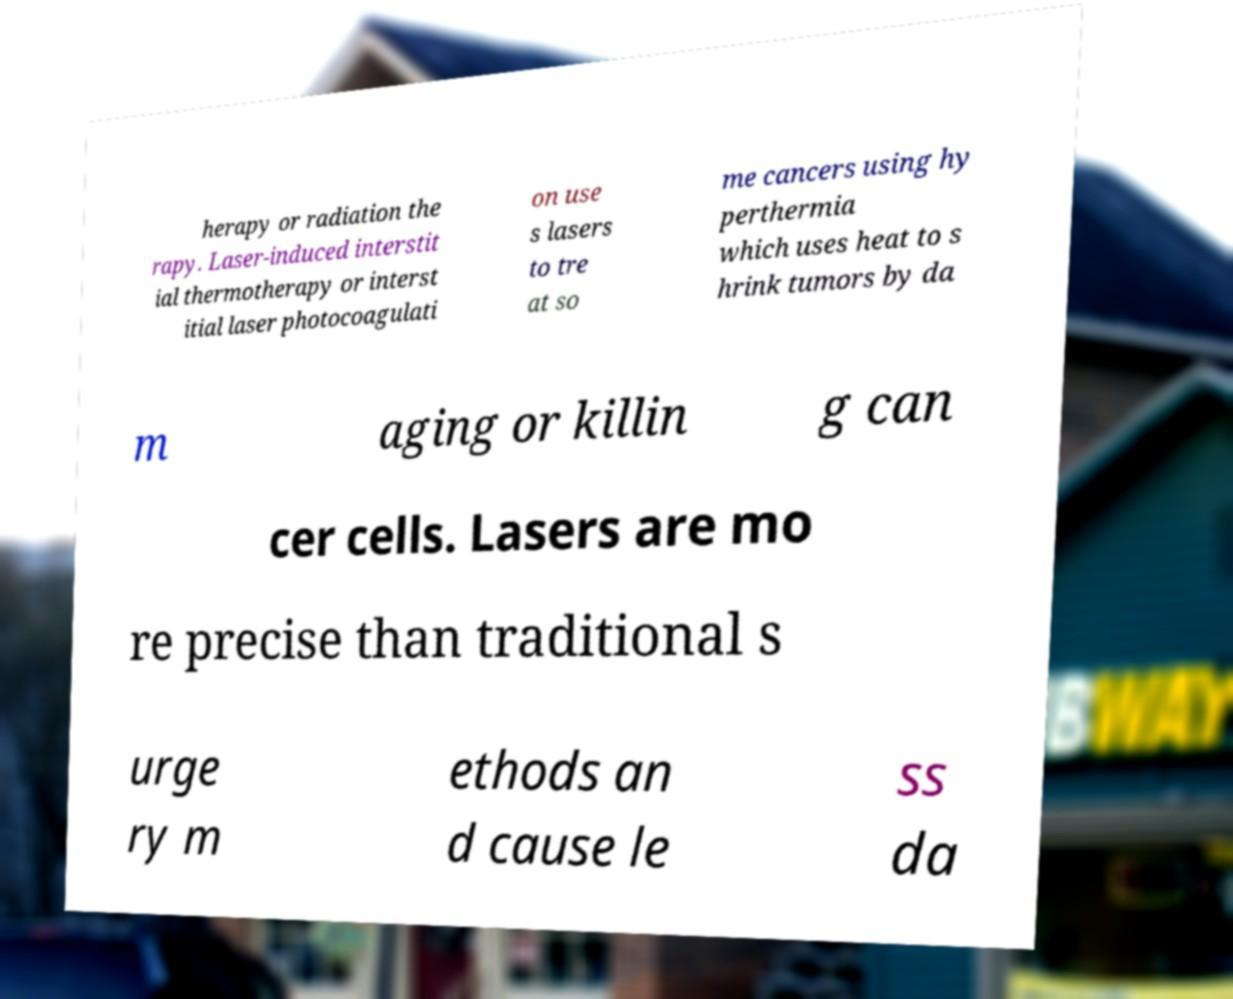Could you extract and type out the text from this image? herapy or radiation the rapy. Laser-induced interstit ial thermotherapy or interst itial laser photocoagulati on use s lasers to tre at so me cancers using hy perthermia which uses heat to s hrink tumors by da m aging or killin g can cer cells. Lasers are mo re precise than traditional s urge ry m ethods an d cause le ss da 